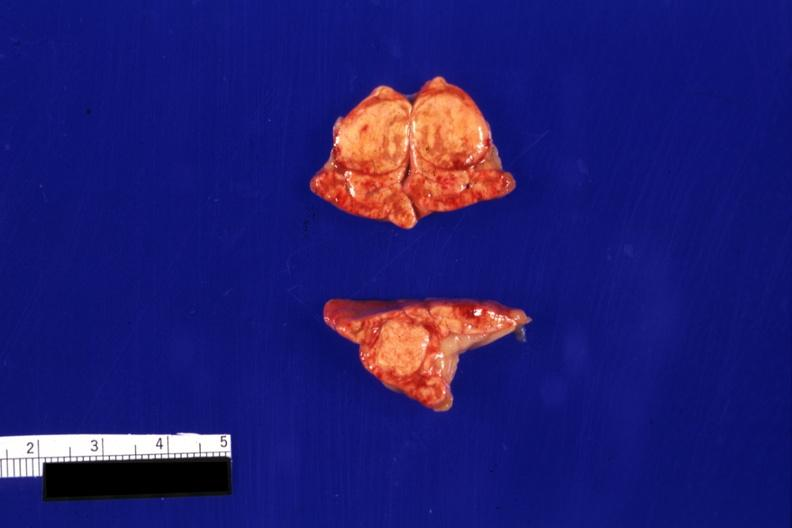s intraductal papillomatosis with apocrine metaplasia present?
Answer the question using a single word or phrase. No 